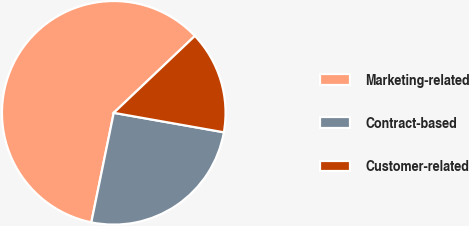Convert chart. <chart><loc_0><loc_0><loc_500><loc_500><pie_chart><fcel>Marketing-related<fcel>Contract-based<fcel>Customer-related<nl><fcel>59.71%<fcel>25.43%<fcel>14.86%<nl></chart> 